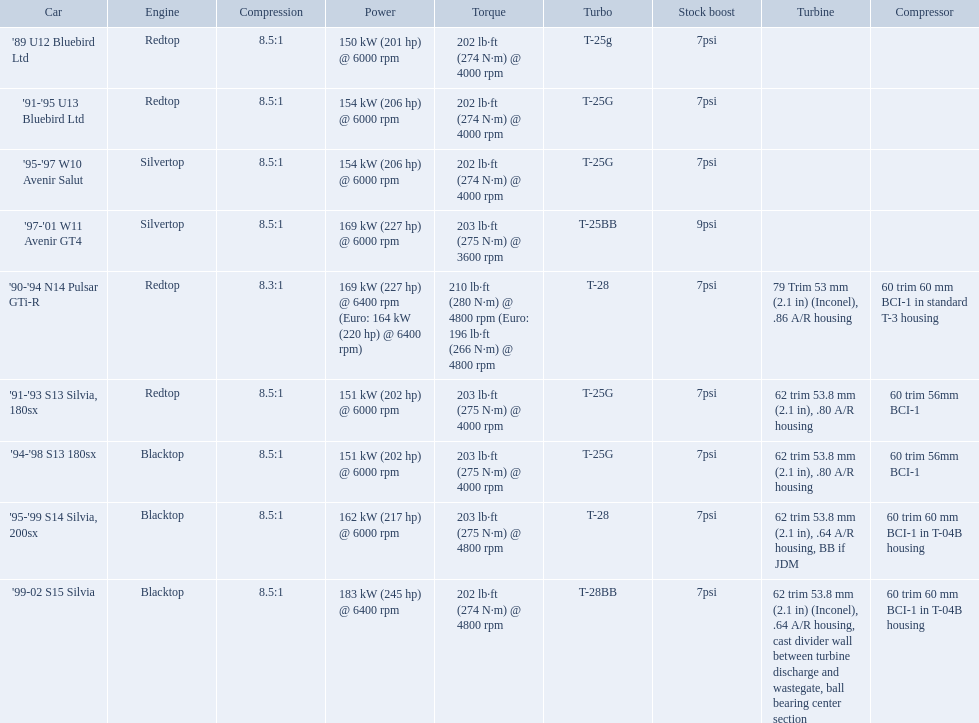What are the psi's? 7psi, 7psi, 7psi, 9psi, 7psi, 7psi, 7psi, 7psi, 7psi. What are the number(s) greater than 7? 9psi. Which car has that number? '97-'01 W11 Avenir GT4. What are all the cars? '89 U12 Bluebird Ltd, '91-'95 U13 Bluebird Ltd, '95-'97 W10 Avenir Salut, '97-'01 W11 Avenir GT4, '90-'94 N14 Pulsar GTi-R, '91-'93 S13 Silvia, 180sx, '94-'98 S13 180sx, '95-'99 S14 Silvia, 200sx, '99-02 S15 Silvia. What are their stock boosts? 7psi, 7psi, 7psi, 9psi, 7psi, 7psi, 7psi, 7psi, 7psi. And which car has the highest stock boost? '97-'01 W11 Avenir GT4. Which vehicles included blacktop engines? '94-'98 S13 180sx, '95-'99 S14 Silvia, 200sx, '99-02 S15 Silvia. Which of these had t-04b compressor casings? '95-'99 S14 Silvia, 200sx, '99-02 S15 Silvia. Which one of these has the highest horsepower? '99-02 S15 Silvia. Which automobiles provide turbine specifications? '90-'94 N14 Pulsar GTi-R, '91-'93 S13 Silvia, 180sx, '94-'98 S13 180sx, '95-'99 S14 Silvia, 200sx, '99-02 S15 Silvia. Which among these reach their maximum horsepower at the highest revolutions per minute? '90-'94 N14 Pulsar GTi-R, '99-02 S15 Silvia. Of these, what is the compression ratio of the sole engine that isn't a blacktop? 8.3:1. What are the psi measurements? 7psi, 7psi, 7psi, 9psi, 7psi, 7psi, 7psi, 7psi, 7psi. What are the digit(s) exceeding 7? 9psi. Which vehicle has that digit? '97-'01 W11 Avenir GT4. Which car models present turbine features? '90-'94 N14 Pulsar GTi-R, '91-'93 S13 Silvia, 180sx, '94-'98 S13 180sx, '95-'99 S14 Silvia, 200sx, '99-02 S15 Silvia. Which of these attain their top horsepower at the highest rpm? '90-'94 N14 Pulsar GTi-R, '99-02 S15 Silvia. Of those, what is the compression level of the unique engine that isn't blacktop? 8.3:1. In which automobiles were blacktop engines present? '94-'98 S13 180sx, '95-'99 S14 Silvia, 200sx, '99-02 S15 Silvia. Which ones also had t-04b compressor housings? '95-'99 S14 Silvia, 200sx, '99-02 S15 Silvia. Which of them boasts the highest horsepower? '99-02 S15 Silvia. Can you list all car models? '89 U12 Bluebird Ltd, '91-'95 U13 Bluebird Ltd, '95-'97 W10 Avenir Salut, '97-'01 W11 Avenir GT4, '90-'94 N14 Pulsar GTi-R, '91-'93 S13 Silvia, 180sx, '94-'98 S13 180sx, '95-'99 S14 Silvia, 200sx, '99-02 S15 Silvia. What power rating do they have? 150 kW (201 hp) @ 6000 rpm, 154 kW (206 hp) @ 6000 rpm, 154 kW (206 hp) @ 6000 rpm, 169 kW (227 hp) @ 6000 rpm, 169 kW (227 hp) @ 6400 rpm (Euro: 164 kW (220 hp) @ 6400 rpm), 151 kW (202 hp) @ 6000 rpm, 151 kW (202 hp) @ 6000 rpm, 162 kW (217 hp) @ 6000 rpm, 183 kW (245 hp) @ 6400 rpm. Which one has the greatest power output? '99-02 S15 Silvia. What types of cars are there? '89 U12 Bluebird Ltd, '91-'95 U13 Bluebird Ltd, '95-'97 W10 Avenir Salut, '97-'01 W11 Avenir GT4, '90-'94 N14 Pulsar GTi-R, '91-'93 S13 Silvia, 180sx, '94-'98 S13 180sx, '95-'99 S14 Silvia, 200sx, '99-02 S15 Silvia. What are their power ratings? 150 kW (201 hp) @ 6000 rpm, 154 kW (206 hp) @ 6000 rpm, 154 kW (206 hp) @ 6000 rpm, 169 kW (227 hp) @ 6000 rpm, 169 kW (227 hp) @ 6400 rpm (Euro: 164 kW (220 hp) @ 6400 rpm), 151 kW (202 hp) @ 6000 rpm, 151 kW (202 hp) @ 6000 rpm, 162 kW (217 hp) @ 6000 rpm, 183 kW (245 hp) @ 6400 rpm. Which car possesses the maximum power? '99-02 S15 Silvia. What do the psi's consist of? 7psi, 7psi, 7psi, 9psi, 7psi, 7psi, 7psi, 7psi, 7psi. What digits are higher than 7? 9psi. Which automobile possesses that figure? '97-'01 W11 Avenir GT4. Which automobiles provide information about turbine specifications? '90-'94 N14 Pulsar GTi-R, '91-'93 S13 Silvia, 180sx, '94-'98 S13 180sx, '95-'99 S14 Silvia, 200sx, '99-02 S15 Silvia. Among them, which reaches maximum horsepower at the highest revolutions per minute? '90-'94 N14 Pulsar GTi-R, '99-02 S15 Silvia. Furthermore, what is the compression ratio of the sole non-blacktop engine? 8.3:1. In which cars can you find turbine-related data? '90-'94 N14 Pulsar GTi-R, '91-'93 S13 Silvia, 180sx, '94-'98 S13 180sx, '95-'99 S14 Silvia, 200sx, '99-02 S15 Silvia. Out of these, which one attains its peak horsepower at the highest rpm? '90-'94 N14 Pulsar GTi-R, '99-02 S15 Silvia. Moreover, what is the compression ratio of the single non-blacktop engine? 8.3:1. 